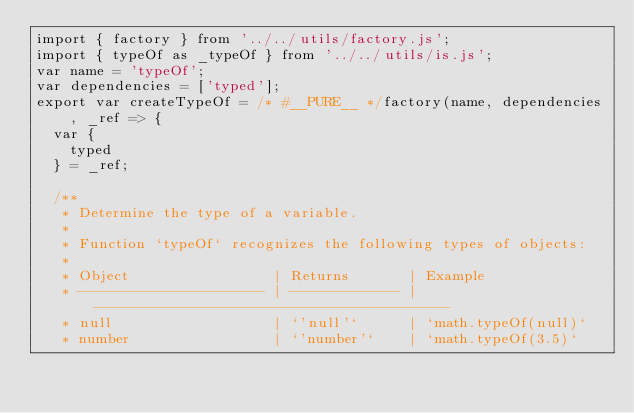<code> <loc_0><loc_0><loc_500><loc_500><_JavaScript_>import { factory } from '../../utils/factory.js';
import { typeOf as _typeOf } from '../../utils/is.js';
var name = 'typeOf';
var dependencies = ['typed'];
export var createTypeOf = /* #__PURE__ */factory(name, dependencies, _ref => {
  var {
    typed
  } = _ref;

  /**
   * Determine the type of a variable.
   *
   * Function `typeOf` recognizes the following types of objects:
   *
   * Object                 | Returns       | Example
   * ---------------------- | ------------- | ------------------------------------------
   * null                   | `'null'`      | `math.typeOf(null)`
   * number                 | `'number'`    | `math.typeOf(3.5)`</code> 